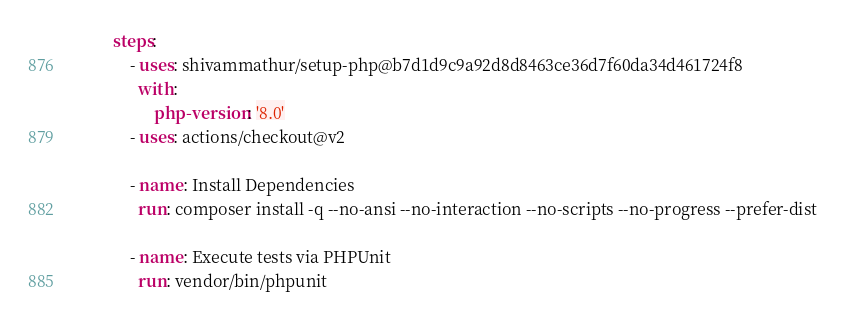Convert code to text. <code><loc_0><loc_0><loc_500><loc_500><_YAML_>        steps:
            - uses: shivammathur/setup-php@b7d1d9c9a92d8d8463ce36d7f60da34d461724f8
              with:
                  php-version: '8.0'
            - uses: actions/checkout@v2

            - name: Install Dependencies
              run: composer install -q --no-ansi --no-interaction --no-scripts --no-progress --prefer-dist

            - name: Execute tests via PHPUnit
              run: vendor/bin/phpunit
</code> 